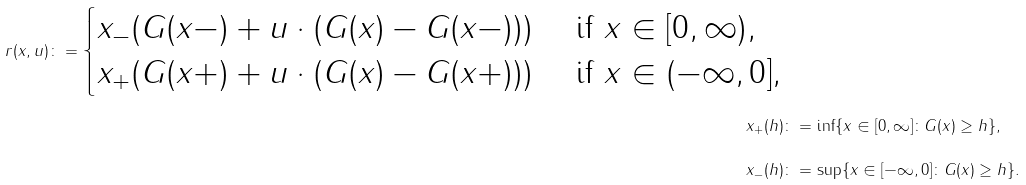Convert formula to latex. <formula><loc_0><loc_0><loc_500><loc_500>\ r ( x , u ) \colon = \begin{cases} x _ { - } ( G ( x - ) + u \cdot ( G ( x ) - G ( x - ) ) ) & \text { if } x \in [ 0 , \infty ) , \\ x _ { + } ( G ( x + ) + u \cdot ( G ( x ) - G ( x + ) ) ) & \text { if } x \in ( - \infty , 0 ] , \end{cases} \\ x _ { + } ( h ) & \colon = \inf \{ x \in [ 0 , \infty ] \colon G ( x ) \geq h \} , \\ x _ { - } ( h ) & \colon = \sup \{ x \in [ - \infty , 0 ] \colon G ( x ) \geq h \} .</formula> 